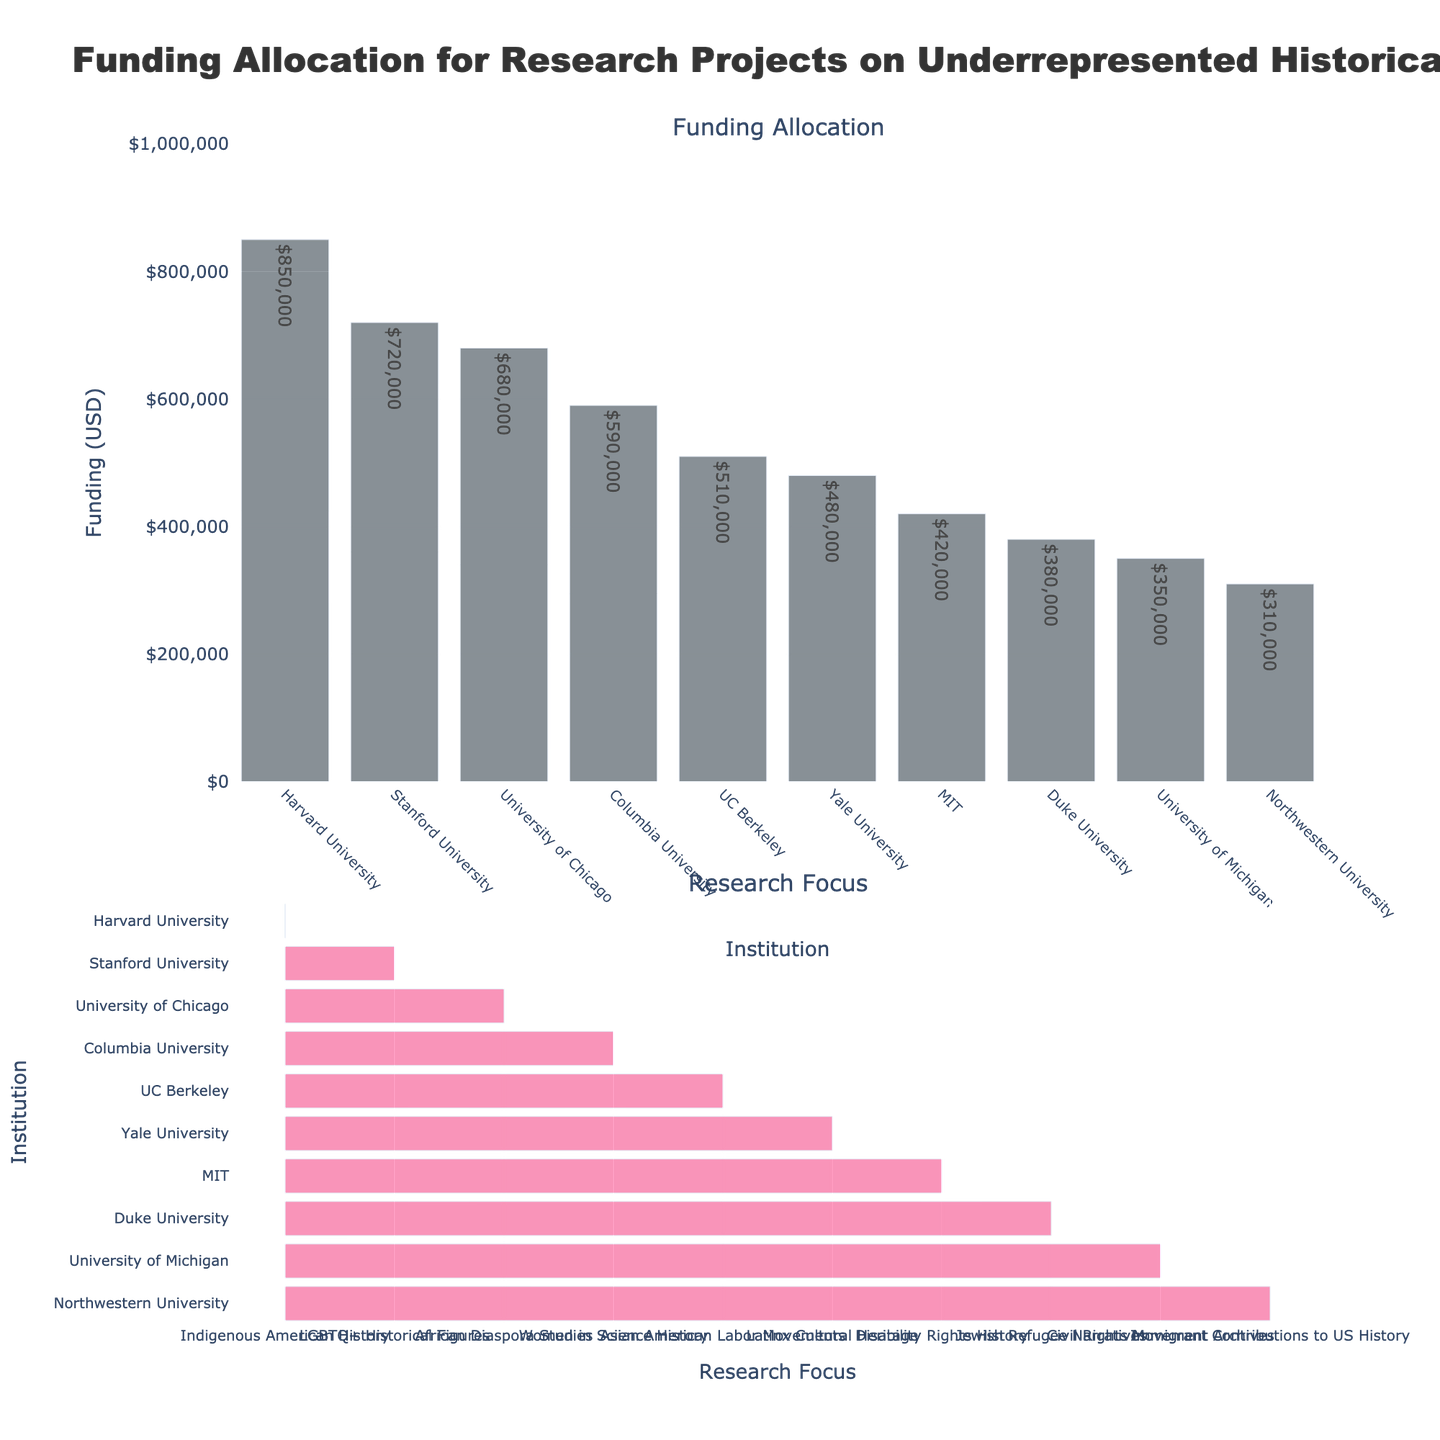What is the title of the plot? The title of the figure is displayed at the top, which reads "Funding Allocation for Research Projects on Underrepresented Historical Narratives".
Answer: "Funding Allocation for Research Projects on Underrepresented Historical Narratives" Which institution received the highest funding? The highest bar in the "Funding Allocation" subplot corresponds to Harvard University, indicating it received the highest funding.
Answer: Harvard University What is the total funding allocated across all institutions? Sum all the funding amounts: 850,000 + 720,000 + 680,000 + 590,000 + 510,000 + 480,000 + 420,000 + 380,000 + 350,000 + 310,000 = 5,290,000 USD.
Answer: 5,290,000 USD Which research focus is funded by Stanford University? In the "Research Focus" subplot, looking horizontally across the row corresponding to Stanford University reveals the research focus as "LGBTQ+ Historical Figures".
Answer: LGBTQ+ Historical Figures How does the funding for Columbia University compare to UC Berkeley? Columbia University has funding of 590,000 USD, while UC Berkeley has 510,000 USD. Therefore, Columbia University received 80,000 USD more in funding than UC Berkeley.
Answer: Columbia University received more Which institution focuses on research related to the Civil Rights Movement Archives? In the "Research Focus" subplot, the institution listed next to "Civil Rights Movement Archives" is the University of Michigan.
Answer: University of Michigan What are the research focuses for the institutions that received less than 500,000 USD in funding? Institutions with less than 500,000 USD funding: Yale University (480,000 USD) - Latinx Cultural Heritage, MIT (420,000 USD) - Disability Rights History, Duke University (380,000 USD) - Jewish Refugee Narratives, University of Michigan (350,000 USD) - Civil Rights Movement Archives, Northwestern University (310,000 USD) - Immigrant Contributions to US History.
Answer: Latinx Cultural Heritage, Disability Rights History, Jewish Refugee Narratives, Civil Rights Movement Archives, Immigrant Contributions to US History What is the average funding for the top five institutions? The top five institutions based on funding are: (850,000, 720,000, 680,000, 590,000, 510,000). Average funding = (850,000 + 720,000 + 680,000 + 590,000 + 510,000) / 5 = 670,000 USD.
Answer: 670,000 USD Which institution received the least funding and what is its research focus? The smallest bar in the "Funding Allocation" subplot is for Northwestern University with 310,000 USD. In the "Research Focus" subplot, Northwestern University focuses on "Immigrant Contributions to US History".
Answer: Northwestern University; Immigrant Contributions to US History 